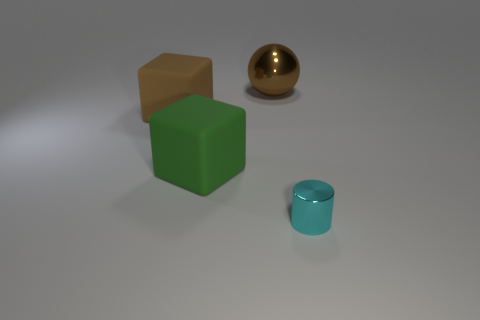Add 2 cyan things. How many objects exist? 6 Subtract all spheres. How many objects are left? 3 Subtract 0 green cylinders. How many objects are left? 4 Subtract all green rubber objects. Subtract all green matte objects. How many objects are left? 2 Add 3 big brown spheres. How many big brown spheres are left? 4 Add 3 large brown objects. How many large brown objects exist? 5 